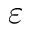<formula> <loc_0><loc_0><loc_500><loc_500>\varepsilon</formula> 